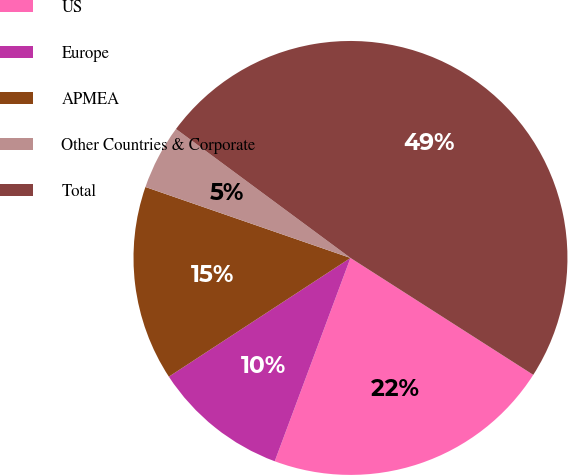<chart> <loc_0><loc_0><loc_500><loc_500><pie_chart><fcel>US<fcel>Europe<fcel>APMEA<fcel>Other Countries & Corporate<fcel>Total<nl><fcel>21.62%<fcel>10.11%<fcel>14.52%<fcel>4.83%<fcel>48.93%<nl></chart> 